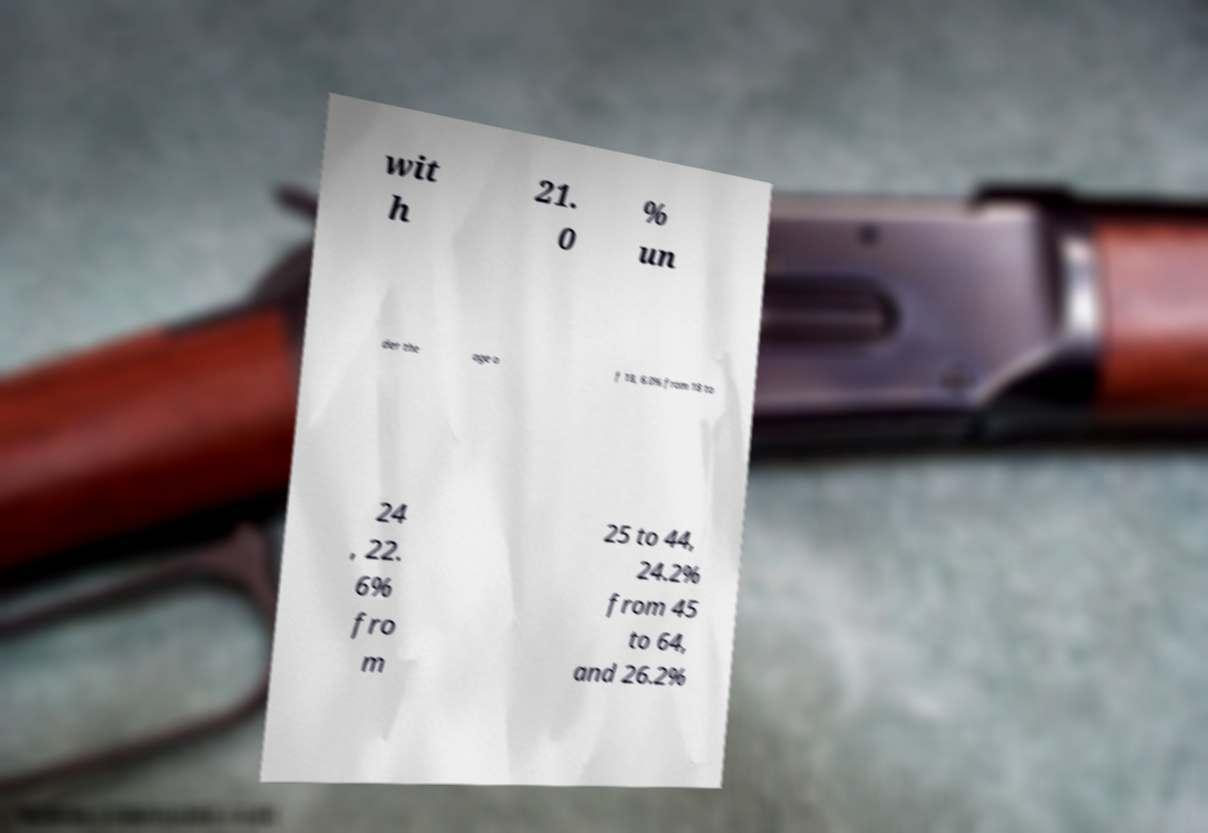Could you assist in decoding the text presented in this image and type it out clearly? wit h 21. 0 % un der the age o f 18, 6.0% from 18 to 24 , 22. 6% fro m 25 to 44, 24.2% from 45 to 64, and 26.2% 